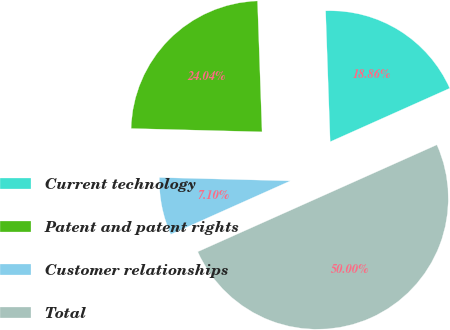Convert chart. <chart><loc_0><loc_0><loc_500><loc_500><pie_chart><fcel>Current technology<fcel>Patent and patent rights<fcel>Customer relationships<fcel>Total<nl><fcel>18.86%<fcel>24.04%<fcel>7.1%<fcel>50.0%<nl></chart> 